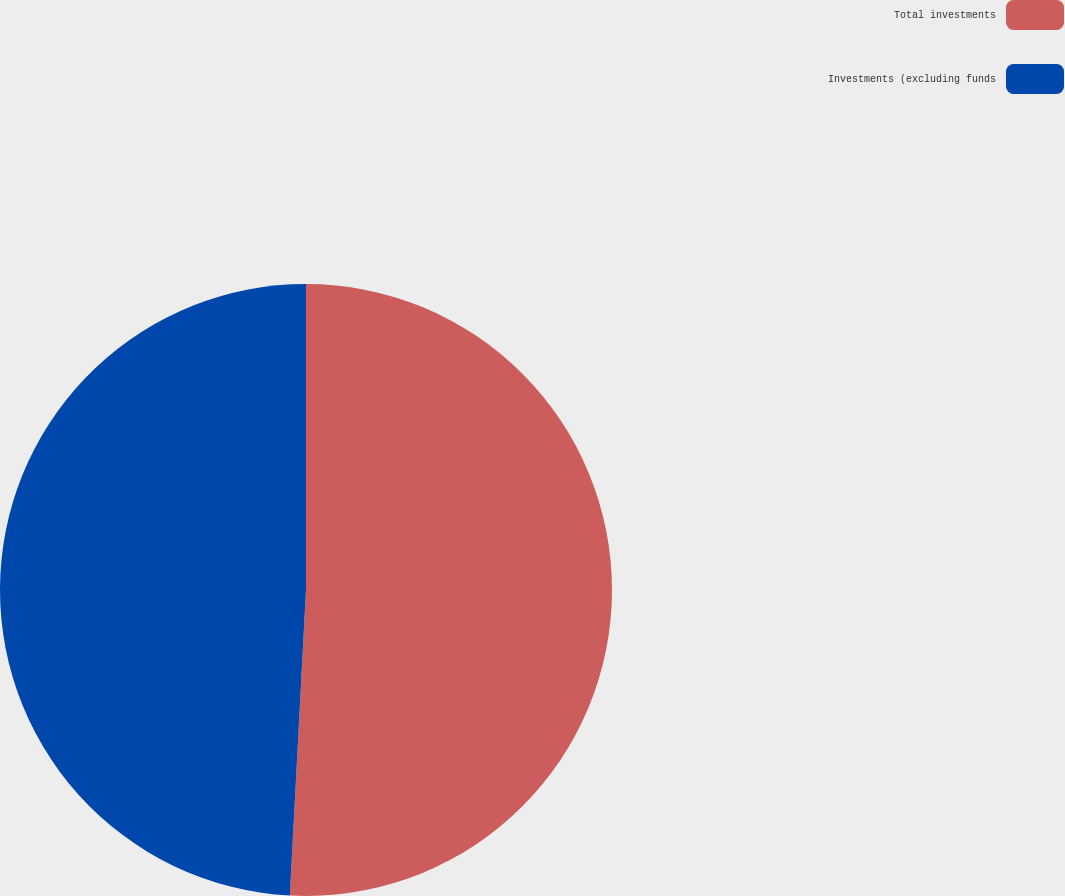Convert chart to OTSL. <chart><loc_0><loc_0><loc_500><loc_500><pie_chart><fcel>Total investments<fcel>Investments (excluding funds<nl><fcel>50.84%<fcel>49.16%<nl></chart> 